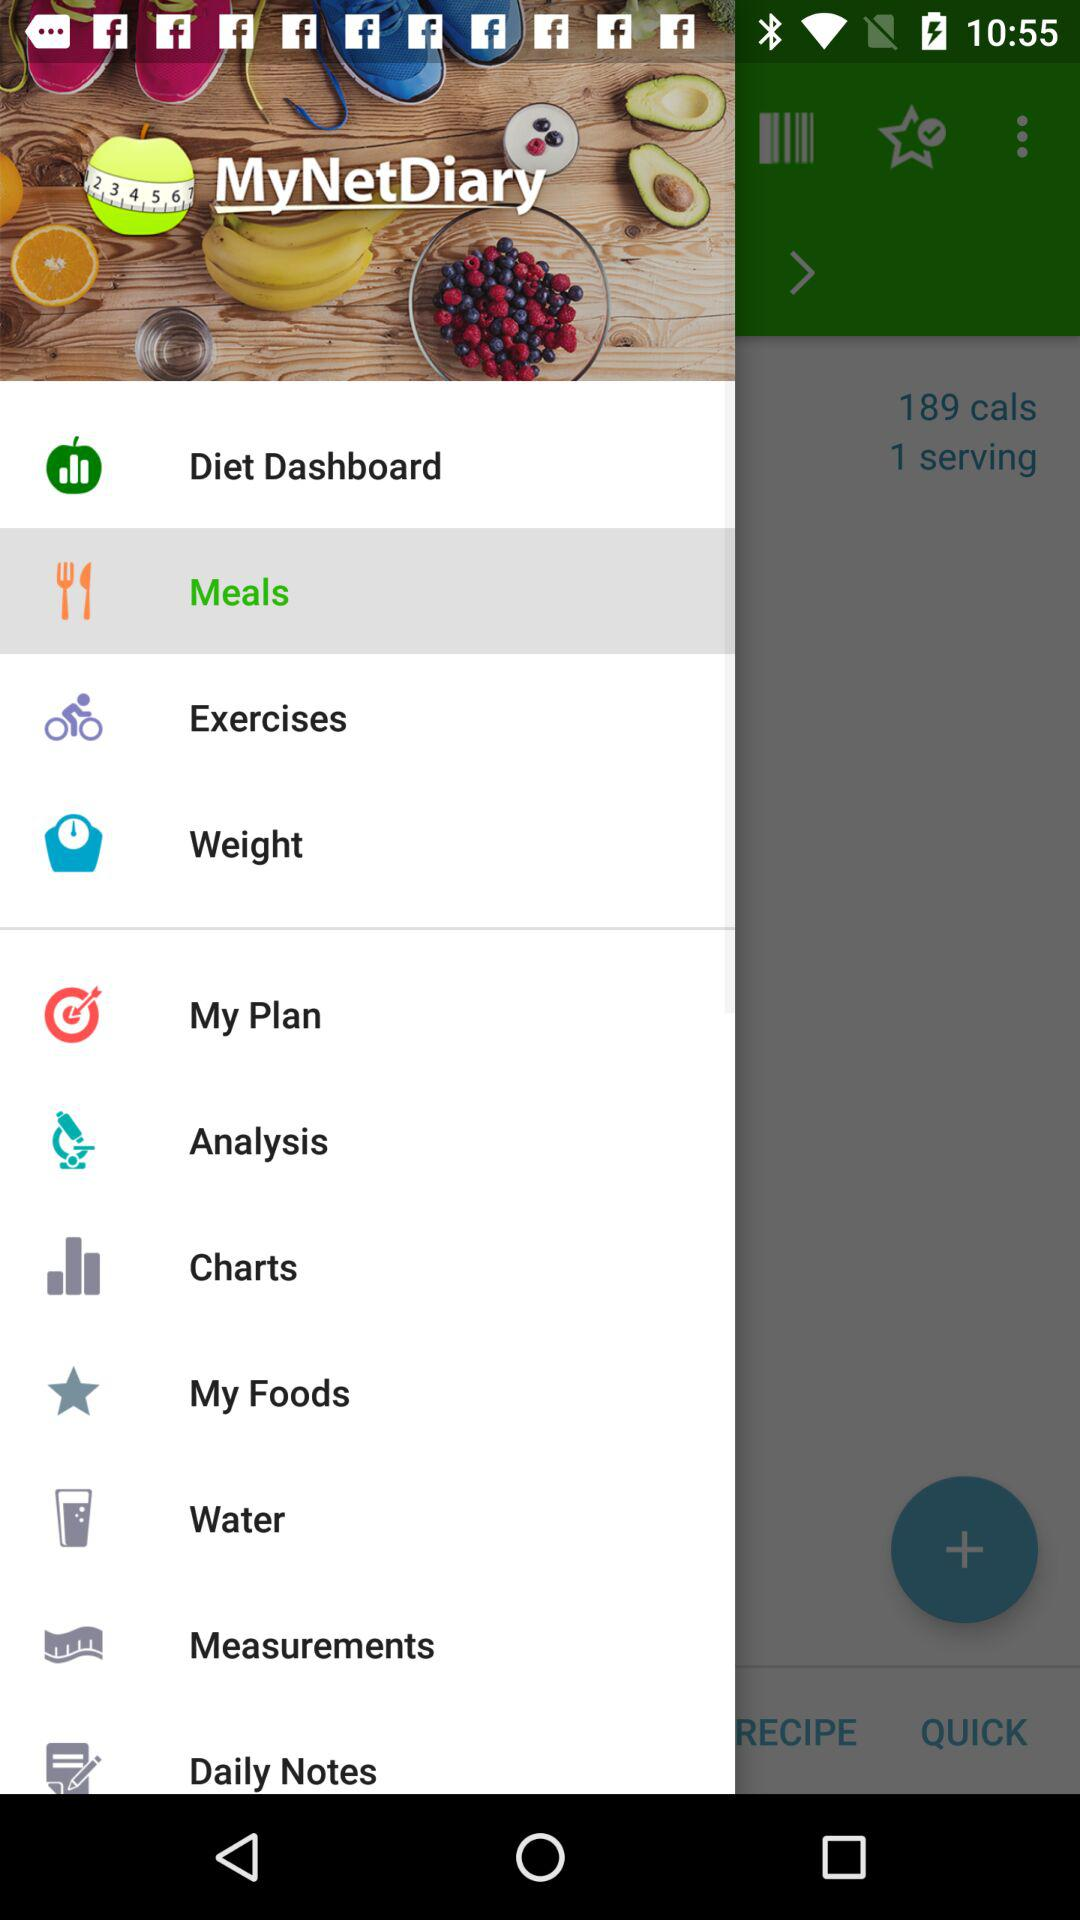Which item is selected? The selected item is "Meals". 